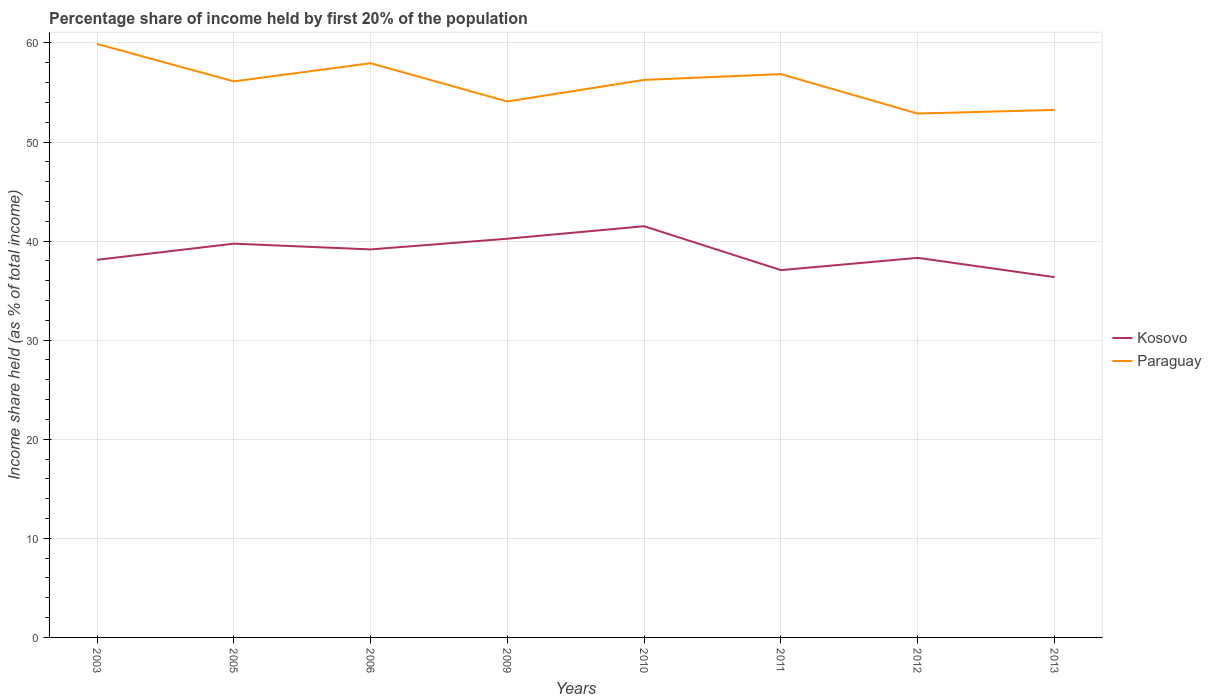How many different coloured lines are there?
Give a very brief answer. 2. Does the line corresponding to Kosovo intersect with the line corresponding to Paraguay?
Offer a terse response. No. Across all years, what is the maximum share of income held by first 20% of the population in Kosovo?
Your response must be concise. 36.36. What is the total share of income held by first 20% of the population in Kosovo in the graph?
Your answer should be very brief. 3.88. What is the difference between the highest and the second highest share of income held by first 20% of the population in Kosovo?
Your answer should be very brief. 5.14. What is the difference between the highest and the lowest share of income held by first 20% of the population in Kosovo?
Provide a short and direct response. 4. Is the share of income held by first 20% of the population in Kosovo strictly greater than the share of income held by first 20% of the population in Paraguay over the years?
Make the answer very short. Yes. How many lines are there?
Provide a succinct answer. 2. Are the values on the major ticks of Y-axis written in scientific E-notation?
Offer a very short reply. No. Does the graph contain grids?
Offer a very short reply. Yes. Where does the legend appear in the graph?
Provide a short and direct response. Center right. What is the title of the graph?
Offer a very short reply. Percentage share of income held by first 20% of the population. Does "Turks and Caicos Islands" appear as one of the legend labels in the graph?
Ensure brevity in your answer.  No. What is the label or title of the Y-axis?
Offer a very short reply. Income share held (as % of total income). What is the Income share held (as % of total income) in Kosovo in 2003?
Give a very brief answer. 38.11. What is the Income share held (as % of total income) in Paraguay in 2003?
Ensure brevity in your answer.  59.9. What is the Income share held (as % of total income) of Kosovo in 2005?
Ensure brevity in your answer.  39.74. What is the Income share held (as % of total income) in Paraguay in 2005?
Your answer should be very brief. 56.12. What is the Income share held (as % of total income) in Kosovo in 2006?
Your answer should be very brief. 39.16. What is the Income share held (as % of total income) of Paraguay in 2006?
Give a very brief answer. 57.95. What is the Income share held (as % of total income) of Kosovo in 2009?
Offer a terse response. 40.24. What is the Income share held (as % of total income) in Paraguay in 2009?
Offer a very short reply. 54.09. What is the Income share held (as % of total income) in Kosovo in 2010?
Your answer should be compact. 41.5. What is the Income share held (as % of total income) in Paraguay in 2010?
Offer a very short reply. 56.27. What is the Income share held (as % of total income) in Kosovo in 2011?
Offer a terse response. 37.07. What is the Income share held (as % of total income) in Paraguay in 2011?
Provide a short and direct response. 56.85. What is the Income share held (as % of total income) in Kosovo in 2012?
Your answer should be very brief. 38.31. What is the Income share held (as % of total income) in Paraguay in 2012?
Your answer should be very brief. 52.87. What is the Income share held (as % of total income) of Kosovo in 2013?
Your answer should be very brief. 36.36. What is the Income share held (as % of total income) of Paraguay in 2013?
Your answer should be very brief. 53.24. Across all years, what is the maximum Income share held (as % of total income) of Kosovo?
Keep it short and to the point. 41.5. Across all years, what is the maximum Income share held (as % of total income) of Paraguay?
Provide a short and direct response. 59.9. Across all years, what is the minimum Income share held (as % of total income) in Kosovo?
Provide a succinct answer. 36.36. Across all years, what is the minimum Income share held (as % of total income) in Paraguay?
Provide a short and direct response. 52.87. What is the total Income share held (as % of total income) of Kosovo in the graph?
Keep it short and to the point. 310.49. What is the total Income share held (as % of total income) in Paraguay in the graph?
Provide a short and direct response. 447.29. What is the difference between the Income share held (as % of total income) in Kosovo in 2003 and that in 2005?
Your answer should be compact. -1.63. What is the difference between the Income share held (as % of total income) in Paraguay in 2003 and that in 2005?
Keep it short and to the point. 3.78. What is the difference between the Income share held (as % of total income) in Kosovo in 2003 and that in 2006?
Your answer should be compact. -1.05. What is the difference between the Income share held (as % of total income) in Paraguay in 2003 and that in 2006?
Keep it short and to the point. 1.95. What is the difference between the Income share held (as % of total income) in Kosovo in 2003 and that in 2009?
Your response must be concise. -2.13. What is the difference between the Income share held (as % of total income) in Paraguay in 2003 and that in 2009?
Your response must be concise. 5.81. What is the difference between the Income share held (as % of total income) in Kosovo in 2003 and that in 2010?
Offer a very short reply. -3.39. What is the difference between the Income share held (as % of total income) of Paraguay in 2003 and that in 2010?
Make the answer very short. 3.63. What is the difference between the Income share held (as % of total income) of Paraguay in 2003 and that in 2011?
Your response must be concise. 3.05. What is the difference between the Income share held (as % of total income) in Paraguay in 2003 and that in 2012?
Make the answer very short. 7.03. What is the difference between the Income share held (as % of total income) in Kosovo in 2003 and that in 2013?
Make the answer very short. 1.75. What is the difference between the Income share held (as % of total income) of Paraguay in 2003 and that in 2013?
Ensure brevity in your answer.  6.66. What is the difference between the Income share held (as % of total income) of Kosovo in 2005 and that in 2006?
Your answer should be compact. 0.58. What is the difference between the Income share held (as % of total income) in Paraguay in 2005 and that in 2006?
Keep it short and to the point. -1.83. What is the difference between the Income share held (as % of total income) of Paraguay in 2005 and that in 2009?
Keep it short and to the point. 2.03. What is the difference between the Income share held (as % of total income) of Kosovo in 2005 and that in 2010?
Keep it short and to the point. -1.76. What is the difference between the Income share held (as % of total income) of Kosovo in 2005 and that in 2011?
Your answer should be very brief. 2.67. What is the difference between the Income share held (as % of total income) of Paraguay in 2005 and that in 2011?
Give a very brief answer. -0.73. What is the difference between the Income share held (as % of total income) in Kosovo in 2005 and that in 2012?
Provide a succinct answer. 1.43. What is the difference between the Income share held (as % of total income) of Kosovo in 2005 and that in 2013?
Provide a succinct answer. 3.38. What is the difference between the Income share held (as % of total income) of Paraguay in 2005 and that in 2013?
Provide a short and direct response. 2.88. What is the difference between the Income share held (as % of total income) in Kosovo in 2006 and that in 2009?
Ensure brevity in your answer.  -1.08. What is the difference between the Income share held (as % of total income) of Paraguay in 2006 and that in 2009?
Make the answer very short. 3.86. What is the difference between the Income share held (as % of total income) of Kosovo in 2006 and that in 2010?
Your answer should be very brief. -2.34. What is the difference between the Income share held (as % of total income) in Paraguay in 2006 and that in 2010?
Your answer should be compact. 1.68. What is the difference between the Income share held (as % of total income) in Kosovo in 2006 and that in 2011?
Your answer should be compact. 2.09. What is the difference between the Income share held (as % of total income) in Paraguay in 2006 and that in 2011?
Give a very brief answer. 1.1. What is the difference between the Income share held (as % of total income) of Paraguay in 2006 and that in 2012?
Provide a short and direct response. 5.08. What is the difference between the Income share held (as % of total income) of Kosovo in 2006 and that in 2013?
Make the answer very short. 2.8. What is the difference between the Income share held (as % of total income) of Paraguay in 2006 and that in 2013?
Provide a succinct answer. 4.71. What is the difference between the Income share held (as % of total income) of Kosovo in 2009 and that in 2010?
Offer a terse response. -1.26. What is the difference between the Income share held (as % of total income) of Paraguay in 2009 and that in 2010?
Give a very brief answer. -2.18. What is the difference between the Income share held (as % of total income) of Kosovo in 2009 and that in 2011?
Your answer should be very brief. 3.17. What is the difference between the Income share held (as % of total income) in Paraguay in 2009 and that in 2011?
Offer a very short reply. -2.76. What is the difference between the Income share held (as % of total income) of Kosovo in 2009 and that in 2012?
Make the answer very short. 1.93. What is the difference between the Income share held (as % of total income) in Paraguay in 2009 and that in 2012?
Your response must be concise. 1.22. What is the difference between the Income share held (as % of total income) in Kosovo in 2009 and that in 2013?
Provide a short and direct response. 3.88. What is the difference between the Income share held (as % of total income) of Paraguay in 2009 and that in 2013?
Make the answer very short. 0.85. What is the difference between the Income share held (as % of total income) in Kosovo in 2010 and that in 2011?
Your answer should be very brief. 4.43. What is the difference between the Income share held (as % of total income) in Paraguay in 2010 and that in 2011?
Make the answer very short. -0.58. What is the difference between the Income share held (as % of total income) of Kosovo in 2010 and that in 2012?
Offer a very short reply. 3.19. What is the difference between the Income share held (as % of total income) in Kosovo in 2010 and that in 2013?
Give a very brief answer. 5.14. What is the difference between the Income share held (as % of total income) of Paraguay in 2010 and that in 2013?
Offer a terse response. 3.03. What is the difference between the Income share held (as % of total income) in Kosovo in 2011 and that in 2012?
Your answer should be compact. -1.24. What is the difference between the Income share held (as % of total income) in Paraguay in 2011 and that in 2012?
Provide a succinct answer. 3.98. What is the difference between the Income share held (as % of total income) in Kosovo in 2011 and that in 2013?
Offer a very short reply. 0.71. What is the difference between the Income share held (as % of total income) of Paraguay in 2011 and that in 2013?
Your answer should be compact. 3.61. What is the difference between the Income share held (as % of total income) in Kosovo in 2012 and that in 2013?
Offer a terse response. 1.95. What is the difference between the Income share held (as % of total income) of Paraguay in 2012 and that in 2013?
Give a very brief answer. -0.37. What is the difference between the Income share held (as % of total income) of Kosovo in 2003 and the Income share held (as % of total income) of Paraguay in 2005?
Ensure brevity in your answer.  -18.01. What is the difference between the Income share held (as % of total income) in Kosovo in 2003 and the Income share held (as % of total income) in Paraguay in 2006?
Keep it short and to the point. -19.84. What is the difference between the Income share held (as % of total income) of Kosovo in 2003 and the Income share held (as % of total income) of Paraguay in 2009?
Offer a terse response. -15.98. What is the difference between the Income share held (as % of total income) in Kosovo in 2003 and the Income share held (as % of total income) in Paraguay in 2010?
Provide a succinct answer. -18.16. What is the difference between the Income share held (as % of total income) of Kosovo in 2003 and the Income share held (as % of total income) of Paraguay in 2011?
Ensure brevity in your answer.  -18.74. What is the difference between the Income share held (as % of total income) in Kosovo in 2003 and the Income share held (as % of total income) in Paraguay in 2012?
Your response must be concise. -14.76. What is the difference between the Income share held (as % of total income) in Kosovo in 2003 and the Income share held (as % of total income) in Paraguay in 2013?
Provide a succinct answer. -15.13. What is the difference between the Income share held (as % of total income) of Kosovo in 2005 and the Income share held (as % of total income) of Paraguay in 2006?
Offer a very short reply. -18.21. What is the difference between the Income share held (as % of total income) of Kosovo in 2005 and the Income share held (as % of total income) of Paraguay in 2009?
Keep it short and to the point. -14.35. What is the difference between the Income share held (as % of total income) of Kosovo in 2005 and the Income share held (as % of total income) of Paraguay in 2010?
Offer a very short reply. -16.53. What is the difference between the Income share held (as % of total income) in Kosovo in 2005 and the Income share held (as % of total income) in Paraguay in 2011?
Ensure brevity in your answer.  -17.11. What is the difference between the Income share held (as % of total income) of Kosovo in 2005 and the Income share held (as % of total income) of Paraguay in 2012?
Keep it short and to the point. -13.13. What is the difference between the Income share held (as % of total income) of Kosovo in 2006 and the Income share held (as % of total income) of Paraguay in 2009?
Provide a short and direct response. -14.93. What is the difference between the Income share held (as % of total income) in Kosovo in 2006 and the Income share held (as % of total income) in Paraguay in 2010?
Provide a succinct answer. -17.11. What is the difference between the Income share held (as % of total income) in Kosovo in 2006 and the Income share held (as % of total income) in Paraguay in 2011?
Provide a succinct answer. -17.69. What is the difference between the Income share held (as % of total income) of Kosovo in 2006 and the Income share held (as % of total income) of Paraguay in 2012?
Your response must be concise. -13.71. What is the difference between the Income share held (as % of total income) of Kosovo in 2006 and the Income share held (as % of total income) of Paraguay in 2013?
Your answer should be compact. -14.08. What is the difference between the Income share held (as % of total income) of Kosovo in 2009 and the Income share held (as % of total income) of Paraguay in 2010?
Provide a succinct answer. -16.03. What is the difference between the Income share held (as % of total income) in Kosovo in 2009 and the Income share held (as % of total income) in Paraguay in 2011?
Offer a very short reply. -16.61. What is the difference between the Income share held (as % of total income) of Kosovo in 2009 and the Income share held (as % of total income) of Paraguay in 2012?
Ensure brevity in your answer.  -12.63. What is the difference between the Income share held (as % of total income) of Kosovo in 2010 and the Income share held (as % of total income) of Paraguay in 2011?
Offer a very short reply. -15.35. What is the difference between the Income share held (as % of total income) of Kosovo in 2010 and the Income share held (as % of total income) of Paraguay in 2012?
Keep it short and to the point. -11.37. What is the difference between the Income share held (as % of total income) in Kosovo in 2010 and the Income share held (as % of total income) in Paraguay in 2013?
Keep it short and to the point. -11.74. What is the difference between the Income share held (as % of total income) of Kosovo in 2011 and the Income share held (as % of total income) of Paraguay in 2012?
Provide a short and direct response. -15.8. What is the difference between the Income share held (as % of total income) of Kosovo in 2011 and the Income share held (as % of total income) of Paraguay in 2013?
Your answer should be compact. -16.17. What is the difference between the Income share held (as % of total income) of Kosovo in 2012 and the Income share held (as % of total income) of Paraguay in 2013?
Offer a terse response. -14.93. What is the average Income share held (as % of total income) of Kosovo per year?
Your answer should be compact. 38.81. What is the average Income share held (as % of total income) of Paraguay per year?
Give a very brief answer. 55.91. In the year 2003, what is the difference between the Income share held (as % of total income) of Kosovo and Income share held (as % of total income) of Paraguay?
Give a very brief answer. -21.79. In the year 2005, what is the difference between the Income share held (as % of total income) in Kosovo and Income share held (as % of total income) in Paraguay?
Offer a terse response. -16.38. In the year 2006, what is the difference between the Income share held (as % of total income) in Kosovo and Income share held (as % of total income) in Paraguay?
Make the answer very short. -18.79. In the year 2009, what is the difference between the Income share held (as % of total income) in Kosovo and Income share held (as % of total income) in Paraguay?
Make the answer very short. -13.85. In the year 2010, what is the difference between the Income share held (as % of total income) in Kosovo and Income share held (as % of total income) in Paraguay?
Offer a terse response. -14.77. In the year 2011, what is the difference between the Income share held (as % of total income) in Kosovo and Income share held (as % of total income) in Paraguay?
Your answer should be compact. -19.78. In the year 2012, what is the difference between the Income share held (as % of total income) in Kosovo and Income share held (as % of total income) in Paraguay?
Make the answer very short. -14.56. In the year 2013, what is the difference between the Income share held (as % of total income) of Kosovo and Income share held (as % of total income) of Paraguay?
Give a very brief answer. -16.88. What is the ratio of the Income share held (as % of total income) of Kosovo in 2003 to that in 2005?
Provide a short and direct response. 0.96. What is the ratio of the Income share held (as % of total income) in Paraguay in 2003 to that in 2005?
Your response must be concise. 1.07. What is the ratio of the Income share held (as % of total income) of Kosovo in 2003 to that in 2006?
Give a very brief answer. 0.97. What is the ratio of the Income share held (as % of total income) of Paraguay in 2003 to that in 2006?
Your answer should be compact. 1.03. What is the ratio of the Income share held (as % of total income) in Kosovo in 2003 to that in 2009?
Provide a short and direct response. 0.95. What is the ratio of the Income share held (as % of total income) of Paraguay in 2003 to that in 2009?
Give a very brief answer. 1.11. What is the ratio of the Income share held (as % of total income) in Kosovo in 2003 to that in 2010?
Your response must be concise. 0.92. What is the ratio of the Income share held (as % of total income) in Paraguay in 2003 to that in 2010?
Provide a short and direct response. 1.06. What is the ratio of the Income share held (as % of total income) of Kosovo in 2003 to that in 2011?
Your answer should be very brief. 1.03. What is the ratio of the Income share held (as % of total income) in Paraguay in 2003 to that in 2011?
Offer a terse response. 1.05. What is the ratio of the Income share held (as % of total income) of Paraguay in 2003 to that in 2012?
Give a very brief answer. 1.13. What is the ratio of the Income share held (as % of total income) of Kosovo in 2003 to that in 2013?
Provide a succinct answer. 1.05. What is the ratio of the Income share held (as % of total income) in Paraguay in 2003 to that in 2013?
Your answer should be compact. 1.13. What is the ratio of the Income share held (as % of total income) in Kosovo in 2005 to that in 2006?
Give a very brief answer. 1.01. What is the ratio of the Income share held (as % of total income) in Paraguay in 2005 to that in 2006?
Keep it short and to the point. 0.97. What is the ratio of the Income share held (as % of total income) in Kosovo in 2005 to that in 2009?
Your response must be concise. 0.99. What is the ratio of the Income share held (as % of total income) in Paraguay in 2005 to that in 2009?
Provide a succinct answer. 1.04. What is the ratio of the Income share held (as % of total income) of Kosovo in 2005 to that in 2010?
Your answer should be compact. 0.96. What is the ratio of the Income share held (as % of total income) in Paraguay in 2005 to that in 2010?
Offer a terse response. 1. What is the ratio of the Income share held (as % of total income) in Kosovo in 2005 to that in 2011?
Keep it short and to the point. 1.07. What is the ratio of the Income share held (as % of total income) of Paraguay in 2005 to that in 2011?
Offer a very short reply. 0.99. What is the ratio of the Income share held (as % of total income) of Kosovo in 2005 to that in 2012?
Offer a very short reply. 1.04. What is the ratio of the Income share held (as % of total income) in Paraguay in 2005 to that in 2012?
Make the answer very short. 1.06. What is the ratio of the Income share held (as % of total income) in Kosovo in 2005 to that in 2013?
Offer a very short reply. 1.09. What is the ratio of the Income share held (as % of total income) of Paraguay in 2005 to that in 2013?
Your answer should be very brief. 1.05. What is the ratio of the Income share held (as % of total income) of Kosovo in 2006 to that in 2009?
Ensure brevity in your answer.  0.97. What is the ratio of the Income share held (as % of total income) in Paraguay in 2006 to that in 2009?
Offer a very short reply. 1.07. What is the ratio of the Income share held (as % of total income) in Kosovo in 2006 to that in 2010?
Provide a short and direct response. 0.94. What is the ratio of the Income share held (as % of total income) of Paraguay in 2006 to that in 2010?
Provide a short and direct response. 1.03. What is the ratio of the Income share held (as % of total income) of Kosovo in 2006 to that in 2011?
Your answer should be compact. 1.06. What is the ratio of the Income share held (as % of total income) of Paraguay in 2006 to that in 2011?
Your answer should be very brief. 1.02. What is the ratio of the Income share held (as % of total income) in Kosovo in 2006 to that in 2012?
Your answer should be compact. 1.02. What is the ratio of the Income share held (as % of total income) of Paraguay in 2006 to that in 2012?
Your response must be concise. 1.1. What is the ratio of the Income share held (as % of total income) of Kosovo in 2006 to that in 2013?
Make the answer very short. 1.08. What is the ratio of the Income share held (as % of total income) in Paraguay in 2006 to that in 2013?
Provide a succinct answer. 1.09. What is the ratio of the Income share held (as % of total income) in Kosovo in 2009 to that in 2010?
Provide a short and direct response. 0.97. What is the ratio of the Income share held (as % of total income) in Paraguay in 2009 to that in 2010?
Offer a terse response. 0.96. What is the ratio of the Income share held (as % of total income) in Kosovo in 2009 to that in 2011?
Keep it short and to the point. 1.09. What is the ratio of the Income share held (as % of total income) in Paraguay in 2009 to that in 2011?
Your answer should be compact. 0.95. What is the ratio of the Income share held (as % of total income) of Kosovo in 2009 to that in 2012?
Your answer should be very brief. 1.05. What is the ratio of the Income share held (as % of total income) in Paraguay in 2009 to that in 2012?
Provide a short and direct response. 1.02. What is the ratio of the Income share held (as % of total income) in Kosovo in 2009 to that in 2013?
Provide a short and direct response. 1.11. What is the ratio of the Income share held (as % of total income) of Paraguay in 2009 to that in 2013?
Your response must be concise. 1.02. What is the ratio of the Income share held (as % of total income) of Kosovo in 2010 to that in 2011?
Provide a short and direct response. 1.12. What is the ratio of the Income share held (as % of total income) in Paraguay in 2010 to that in 2012?
Your answer should be compact. 1.06. What is the ratio of the Income share held (as % of total income) of Kosovo in 2010 to that in 2013?
Your response must be concise. 1.14. What is the ratio of the Income share held (as % of total income) of Paraguay in 2010 to that in 2013?
Make the answer very short. 1.06. What is the ratio of the Income share held (as % of total income) of Kosovo in 2011 to that in 2012?
Provide a succinct answer. 0.97. What is the ratio of the Income share held (as % of total income) of Paraguay in 2011 to that in 2012?
Ensure brevity in your answer.  1.08. What is the ratio of the Income share held (as % of total income) of Kosovo in 2011 to that in 2013?
Give a very brief answer. 1.02. What is the ratio of the Income share held (as % of total income) in Paraguay in 2011 to that in 2013?
Keep it short and to the point. 1.07. What is the ratio of the Income share held (as % of total income) in Kosovo in 2012 to that in 2013?
Your answer should be very brief. 1.05. What is the ratio of the Income share held (as % of total income) in Paraguay in 2012 to that in 2013?
Make the answer very short. 0.99. What is the difference between the highest and the second highest Income share held (as % of total income) in Kosovo?
Your response must be concise. 1.26. What is the difference between the highest and the second highest Income share held (as % of total income) of Paraguay?
Make the answer very short. 1.95. What is the difference between the highest and the lowest Income share held (as % of total income) in Kosovo?
Provide a succinct answer. 5.14. What is the difference between the highest and the lowest Income share held (as % of total income) of Paraguay?
Make the answer very short. 7.03. 